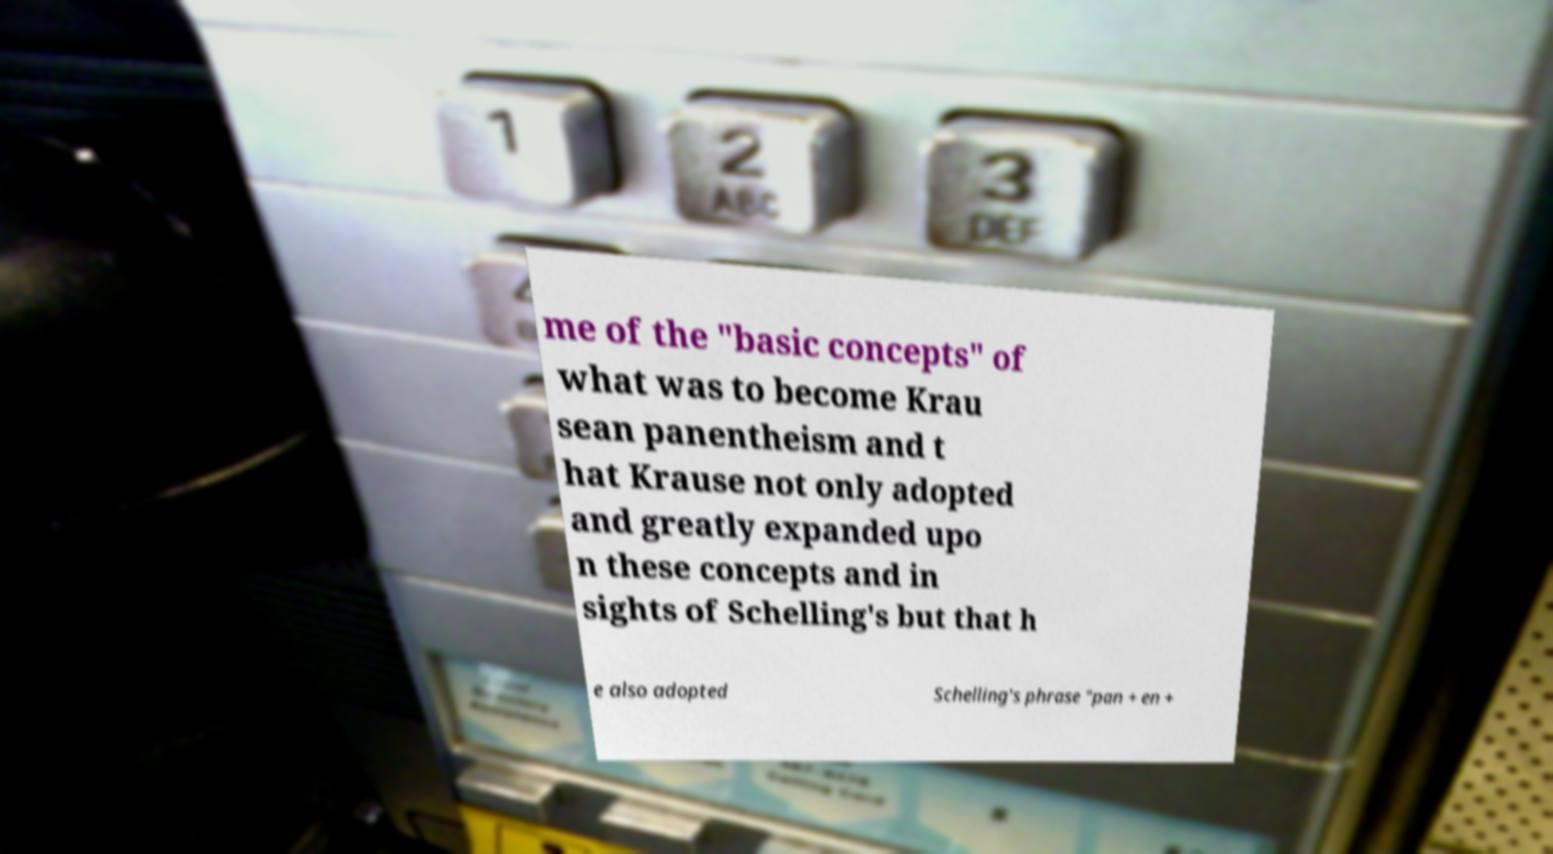Could you extract and type out the text from this image? me of the "basic concepts" of what was to become Krau sean panentheism and t hat Krause not only adopted and greatly expanded upo n these concepts and in sights of Schelling's but that h e also adopted Schelling's phrase "pan + en + 